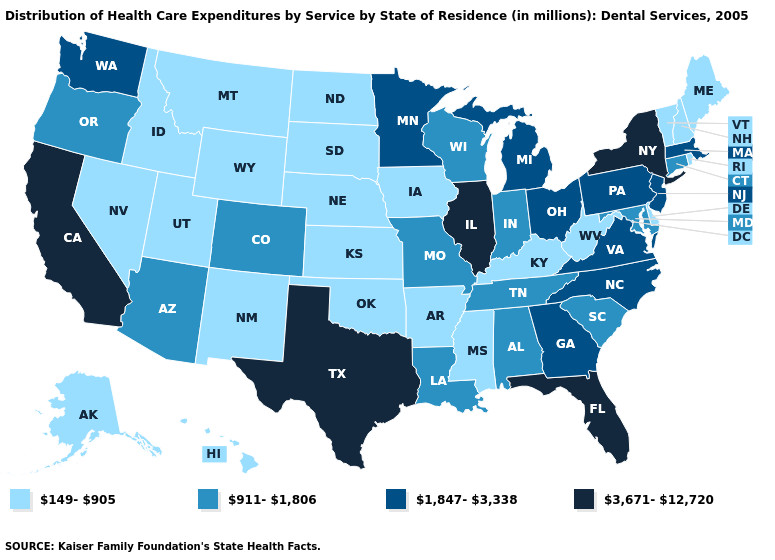Does Arkansas have a lower value than California?
Keep it brief. Yes. Which states have the lowest value in the USA?
Be succinct. Alaska, Arkansas, Delaware, Hawaii, Idaho, Iowa, Kansas, Kentucky, Maine, Mississippi, Montana, Nebraska, Nevada, New Hampshire, New Mexico, North Dakota, Oklahoma, Rhode Island, South Dakota, Utah, Vermont, West Virginia, Wyoming. What is the value of Texas?
Answer briefly. 3,671-12,720. How many symbols are there in the legend?
Keep it brief. 4. What is the value of California?
Quick response, please. 3,671-12,720. Does Arizona have the highest value in the USA?
Keep it brief. No. Name the states that have a value in the range 3,671-12,720?
Give a very brief answer. California, Florida, Illinois, New York, Texas. What is the value of Virginia?
Short answer required. 1,847-3,338. What is the lowest value in the South?
Be succinct. 149-905. Among the states that border California , which have the lowest value?
Short answer required. Nevada. Among the states that border Louisiana , which have the lowest value?
Quick response, please. Arkansas, Mississippi. Does California have the same value as Florida?
Short answer required. Yes. Name the states that have a value in the range 149-905?
Answer briefly. Alaska, Arkansas, Delaware, Hawaii, Idaho, Iowa, Kansas, Kentucky, Maine, Mississippi, Montana, Nebraska, Nevada, New Hampshire, New Mexico, North Dakota, Oklahoma, Rhode Island, South Dakota, Utah, Vermont, West Virginia, Wyoming. Among the states that border North Carolina , which have the lowest value?
Quick response, please. South Carolina, Tennessee. Does Vermont have the same value as Florida?
Quick response, please. No. 